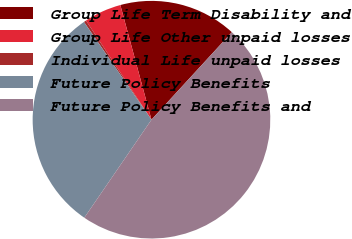<chart> <loc_0><loc_0><loc_500><loc_500><pie_chart><fcel>Group Life Term Disability and<fcel>Group Life Other unpaid losses<fcel>Individual Life unpaid losses<fcel>Future Policy Benefits<fcel>Future Policy Benefits and<nl><fcel>16.05%<fcel>5.07%<fcel>0.33%<fcel>30.82%<fcel>47.73%<nl></chart> 